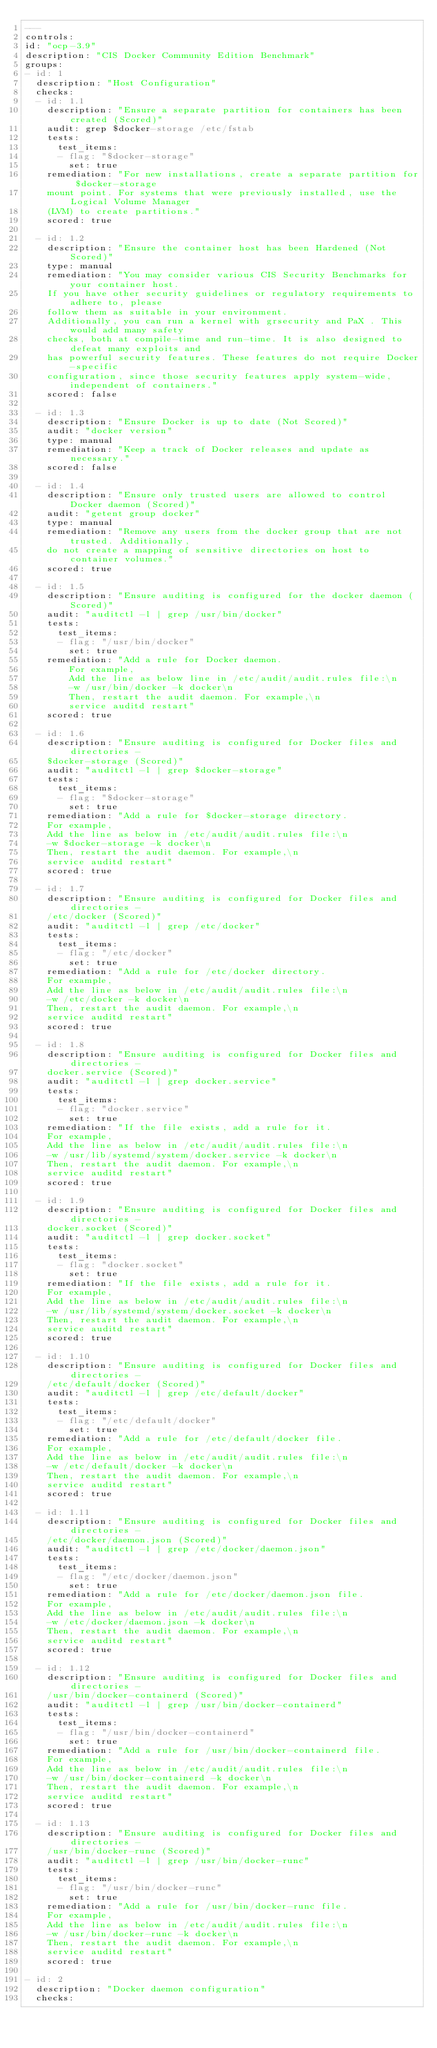Convert code to text. <code><loc_0><loc_0><loc_500><loc_500><_YAML_>---
controls:
id: "ocp-3.9"
description: "CIS Docker Community Edition Benchmark"
groups:
- id: 1
  description: "Host Configuration"
  checks:
  - id: 1.1
    description: "Ensure a separate partition for containers has been created (Scored)"
    audit: grep $docker-storage /etc/fstab
    tests:
      test_items:
      - flag: "$docker-storage"
        set: true
    remediation: "For new installations, create a separate partition for $docker-storage
    mount point. For systems that were previously installed, use the Logical Volume Manager
    (LVM) to create partitions."
    scored: true

  - id: 1.2
    description: "Ensure the container host has been Hardened (Not Scored)"
    type: manual
    remediation: "You may consider various CIS Security Benchmarks for your container host.
    If you have other security guidelines or regulatory requirements to adhere to, please 
    follow them as suitable in your environment.
    Additionally, you can run a kernel with grsecurity and PaX . This would add many safety
    checks, both at compile-time and run-time. It is also designed to defeat many exploits and
    has powerful security features. These features do not require Docker-specific
    configuration, since those security features apply system-wide, independent of containers."
    scored: false

  - id: 1.3
    description: "Ensure Docker is up to date (Not Scored)"
    audit: "docker version"
    type: manual
    remediation: "Keep a track of Docker releases and update as necessary."
    scored: false

  - id: 1.4
    description: "Ensure only trusted users are allowed to control Docker daemon (Scored)"
    audit: "getent group docker"
    type: manual
    remediation: "Remove any users from the docker group that are not trusted. Additionally,
    do not create a mapping of sensitive directories on host to container volumes."
    scored: true

  - id: 1.5
    description: "Ensure auditing is configured for the docker daemon (Scored)"
    audit: "auditctl -l | grep /usr/bin/docker"
    tests:
      test_items:
      - flag: "/usr/bin/docker"
        set: true
    remediation: "Add a rule for Docker daemon.
        For example,
        Add the line as below line in /etc/audit/audit.rules file:\n
        -w /usr/bin/docker -k docker\n
        Then, restart the audit daemon. For example,\n
        service auditd restart"
    scored: true

  - id: 1.6
    description: "Ensure auditing is configured for Docker files and directories - 
    $docker-storage (Scored)"
    audit: "auditctl -l | grep $docker-storage"
    tests:
      test_items:
      - flag: "$docker-storage"
        set: true
    remediation: "Add a rule for $docker-storage directory.
    For example,
    Add the line as below in /etc/audit/audit.rules file:\n
    -w $docker-storage -k docker\n
    Then, restart the audit daemon. For example,\n
    service auditd restart"
    scored: true

  - id: 1.7
    description: "Ensure auditing is configured for Docker files and directories -
    /etc/docker (Scored)"
    audit: "auditctl -l | grep /etc/docker"
    tests:
      test_items:
      - flag: "/etc/docker"
        set: true
    remediation: "Add a rule for /etc/docker directory.
    For example,
    Add the line as below in /etc/audit/audit.rules file:\n
    -w /etc/docker -k docker\n
    Then, restart the audit daemon. For example,\n
    service auditd restart"
    scored: true

  - id: 1.8
    description: "Ensure auditing is configured for Docker files and directories -
    docker.service (Scored)"
    audit: "auditctl -l | grep docker.service"
    tests:
      test_items:
      - flag: "docker.service"
        set: true
    remediation: "If the file exists, add a rule for it.
    For example,
    Add the line as below in /etc/audit/audit.rules file:\n
    -w /usr/lib/systemd/system/docker.service -k docker\n
    Then, restart the audit daemon. For example,\n
    service auditd restart"
    scored: true

  - id: 1.9
    description: "Ensure auditing is configured for Docker files and directories -
    docker.socket (Scored)"
    audit: "auditctl -l | grep docker.socket"
    tests:
      test_items:
      - flag: "docker.socket"
        set: true
    remediation: "If the file exists, add a rule for it.
    For example,
    Add the line as below in /etc/audit/audit.rules file:\n
    -w /usr/lib/systemd/system/docker.socket -k docker\n
    Then, restart the audit daemon. For example,\n
    service auditd restart"
    scored: true

  - id: 1.10
    description: "Ensure auditing is configured for Docker files and directories -
    /etc/default/docker (Scored)"
    audit: "auditctl -l | grep /etc/default/docker"
    tests:
      test_items:
      - flag: "/etc/default/docker"
        set: true
    remediation: "Add a rule for /etc/default/docker file.
    For example,
    Add the line as below in /etc/audit/audit.rules file:\n
    -w /etc/default/docker -k docker\n
    Then, restart the audit daemon. For example,\n
    service auditd restart"
    scored: true

  - id: 1.11
    description: "Ensure auditing is configured for Docker files and directories -
    /etc/docker/daemon.json (Scored)"
    audit: "auditctl -l | grep /etc/docker/daemon.json"
    tests:
      test_items:
      - flag: "/etc/docker/daemon.json"
        set: true
    remediation: "Add a rule for /etc/docker/daemon.json file.
    For example,
    Add the line as below in /etc/audit/audit.rules file:\n
    -w /etc/docker/daemon.json -k docker\n
    Then, restart the audit daemon. For example,\n
    service auditd restart"
    scored: true

  - id: 1.12
    description: "Ensure auditing is configured for Docker files and directories -
    /usr/bin/docker-containerd (Scored)"
    audit: "auditctl -l | grep /usr/bin/docker-containerd"
    tests:
      test_items:
      - flag: "/usr/bin/docker-containerd"
        set: true
    remediation: "Add a rule for /usr/bin/docker-containerd file.
    For example,
    Add the line as below in /etc/audit/audit.rules file:\n
    -w /usr/bin/docker-containerd -k docker\n
    Then, restart the audit daemon. For example,\n
    service auditd restart"
    scored: true

  - id: 1.13
    description: "Ensure auditing is configured for Docker files and directories -
    /usr/bin/docker-runc (Scored)"
    audit: "auditctl -l | grep /usr/bin/docker-runc"
    tests:
      test_items:
      - flag: "/usr/bin/docker-runc"
        set: true
    remediation: "Add a rule for /usr/bin/docker-runc file.
    For example,
    Add the line as below in /etc/audit/audit.rules file:\n
    -w /usr/bin/docker-runc -k docker\n
    Then, restart the audit daemon. For example,\n
    service auditd restart"
    scored: true

- id: 2
  description: "Docker daemon configuration"
  checks:</code> 